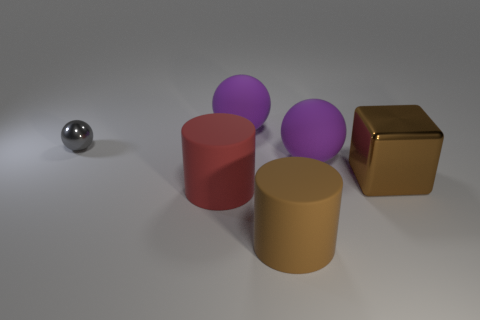Subtract all large balls. How many balls are left? 1 Add 2 brown cylinders. How many objects exist? 8 Subtract all gray balls. How many balls are left? 2 Subtract all cylinders. How many objects are left? 4 Subtract all gray balls. Subtract all big matte spheres. How many objects are left? 3 Add 3 metallic things. How many metallic things are left? 5 Add 5 tiny cyan metallic things. How many tiny cyan metallic things exist? 5 Subtract 0 blue spheres. How many objects are left? 6 Subtract 1 cubes. How many cubes are left? 0 Subtract all purple balls. Subtract all blue cylinders. How many balls are left? 1 